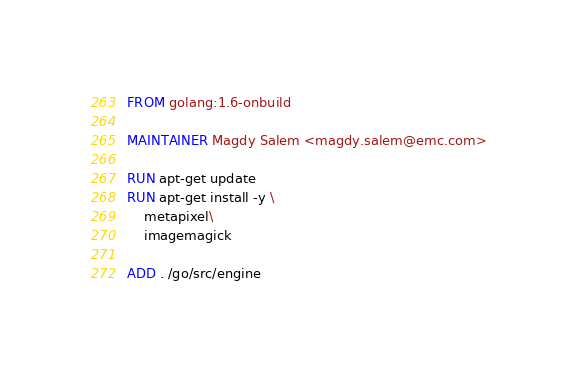<code> <loc_0><loc_0><loc_500><loc_500><_Dockerfile_>FROM golang:1.6-onbuild

MAINTAINER Magdy Salem <magdy.salem@emc.com>

RUN apt-get update
RUN apt-get install -y \
    metapixel\
    imagemagick

ADD . /go/src/engine


</code> 